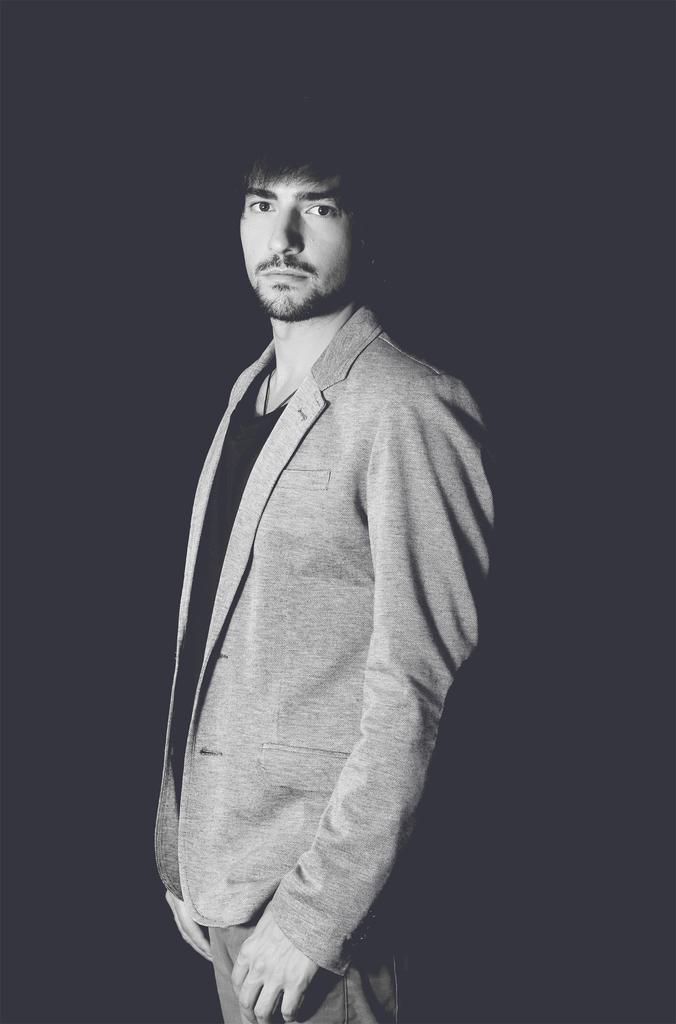How would you summarize this image in a sentence or two? In this image we can see a man is standing, he is wearing the suit, the background is dark. 